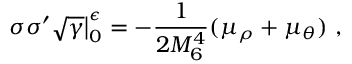<formula> <loc_0><loc_0><loc_500><loc_500>\sigma \sigma ^ { \prime } \sqrt { \gamma } \Big | _ { 0 } ^ { \epsilon } = - \frac { 1 } { 2 M _ { 6 } ^ { 4 } } ( \mu _ { \rho } + \mu _ { \theta } ) ,</formula> 